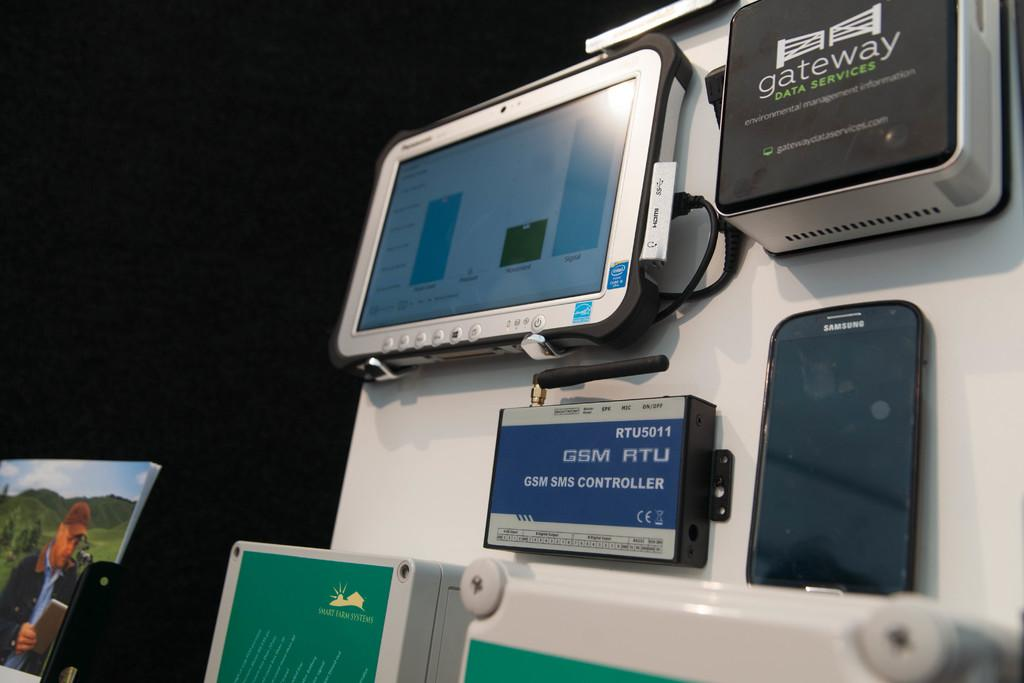What electronic device is present in the image? There is a mobile phone in the image. What other devices can be seen in the image? There are devices towards the right side of the image. Can you describe the person visible on a screen in the image? There is a person visible on a screen towards the left corner of the image. What type of garden can be seen in the image? There is no garden present in the image. How does the person on the screen breathe in the image? The person on the screen is not a real person, but rather an image or video, so the concept of breathing does not apply. 